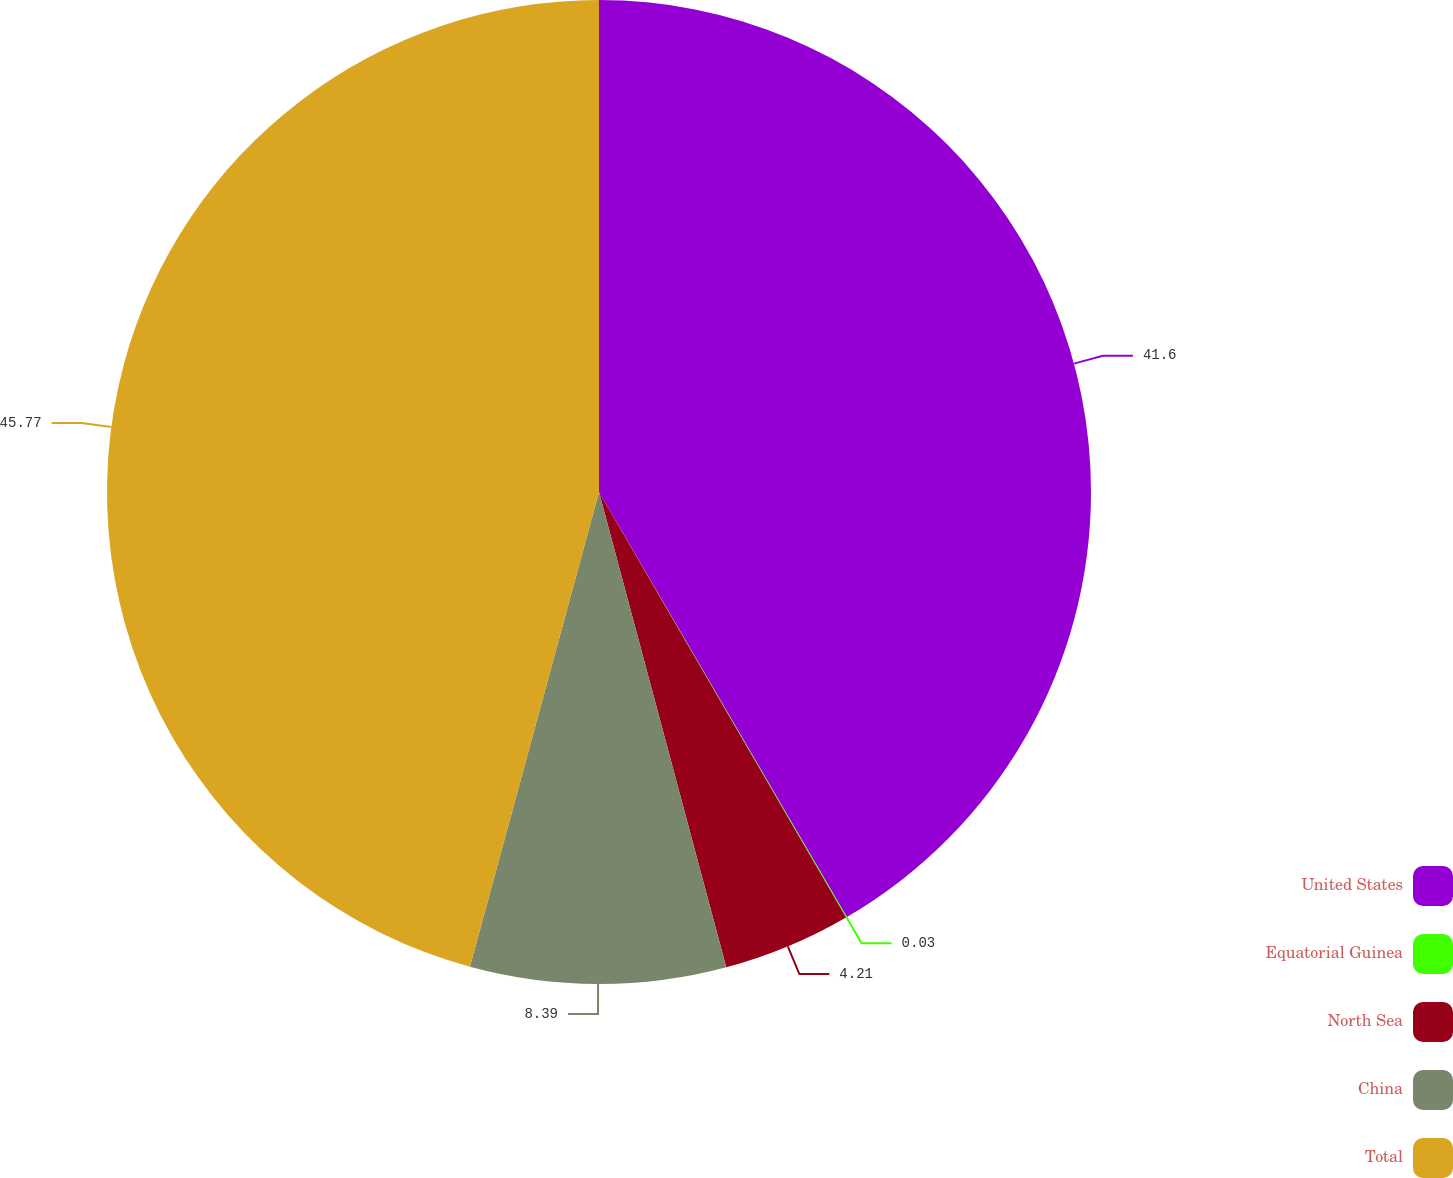Convert chart to OTSL. <chart><loc_0><loc_0><loc_500><loc_500><pie_chart><fcel>United States<fcel>Equatorial Guinea<fcel>North Sea<fcel>China<fcel>Total<nl><fcel>41.6%<fcel>0.03%<fcel>4.21%<fcel>8.39%<fcel>45.78%<nl></chart> 